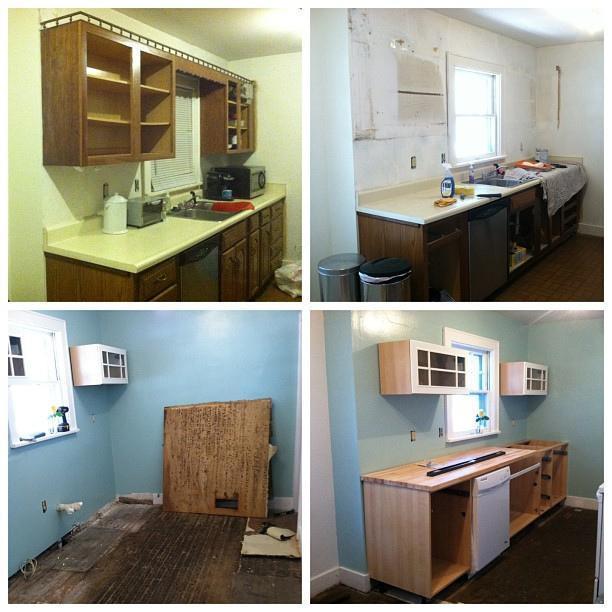How many pictures are shown here?
Give a very brief answer. 4. How many umbrellas are pictured?
Give a very brief answer. 0. 